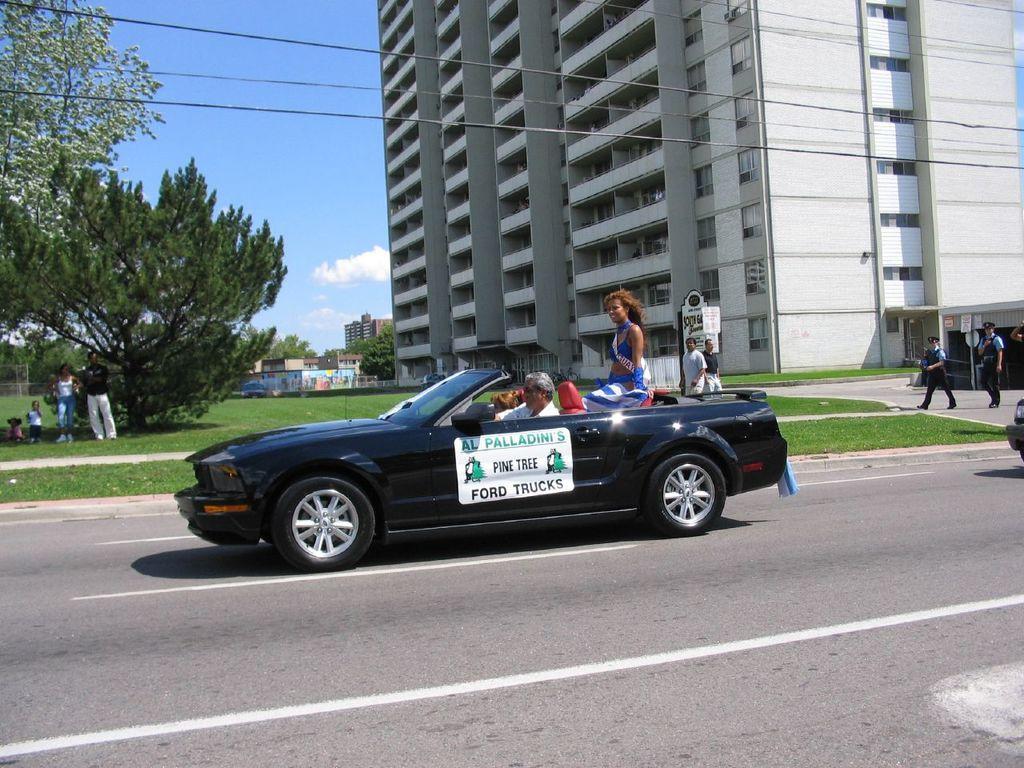In one or two sentences, can you explain what this image depicts? In this image we can see few people on the grass, few people walking on the road, there is a car on the road and some of them are sitting in the car, there are few buildings, trees and the sky in the background. 